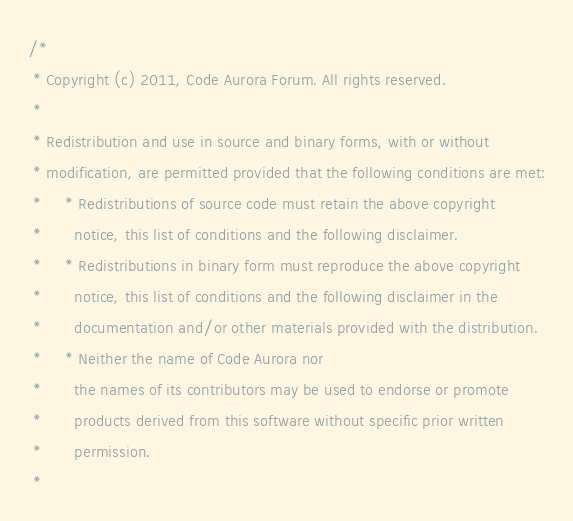Convert code to text. <code><loc_0><loc_0><loc_500><loc_500><_C_>/*
 * Copyright (c) 2011, Code Aurora Forum. All rights reserved.
 *
 * Redistribution and use in source and binary forms, with or without
 * modification, are permitted provided that the following conditions are met:
 *     * Redistributions of source code must retain the above copyright
 *       notice, this list of conditions and the following disclaimer.
 *     * Redistributions in binary form must reproduce the above copyright
 *       notice, this list of conditions and the following disclaimer in the
 *       documentation and/or other materials provided with the distribution.
 *     * Neither the name of Code Aurora nor
 *       the names of its contributors may be used to endorse or promote
 *       products derived from this software without specific prior written
 *       permission.
 *</code> 